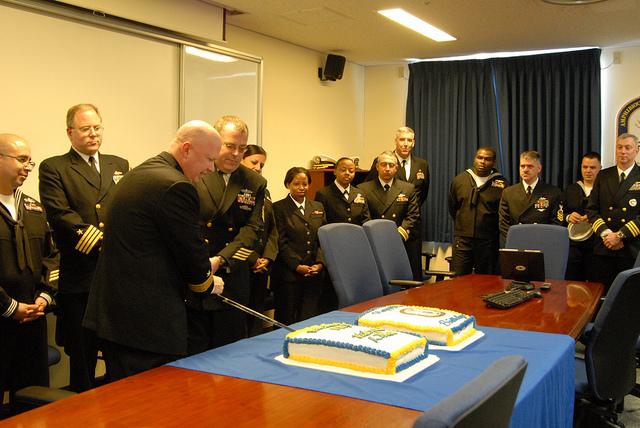What is the color of the curtains?
Be succinct. Blue. Are these military people?
Give a very brief answer. Yes. How many cakes are on the table?
Write a very short answer. 2. 